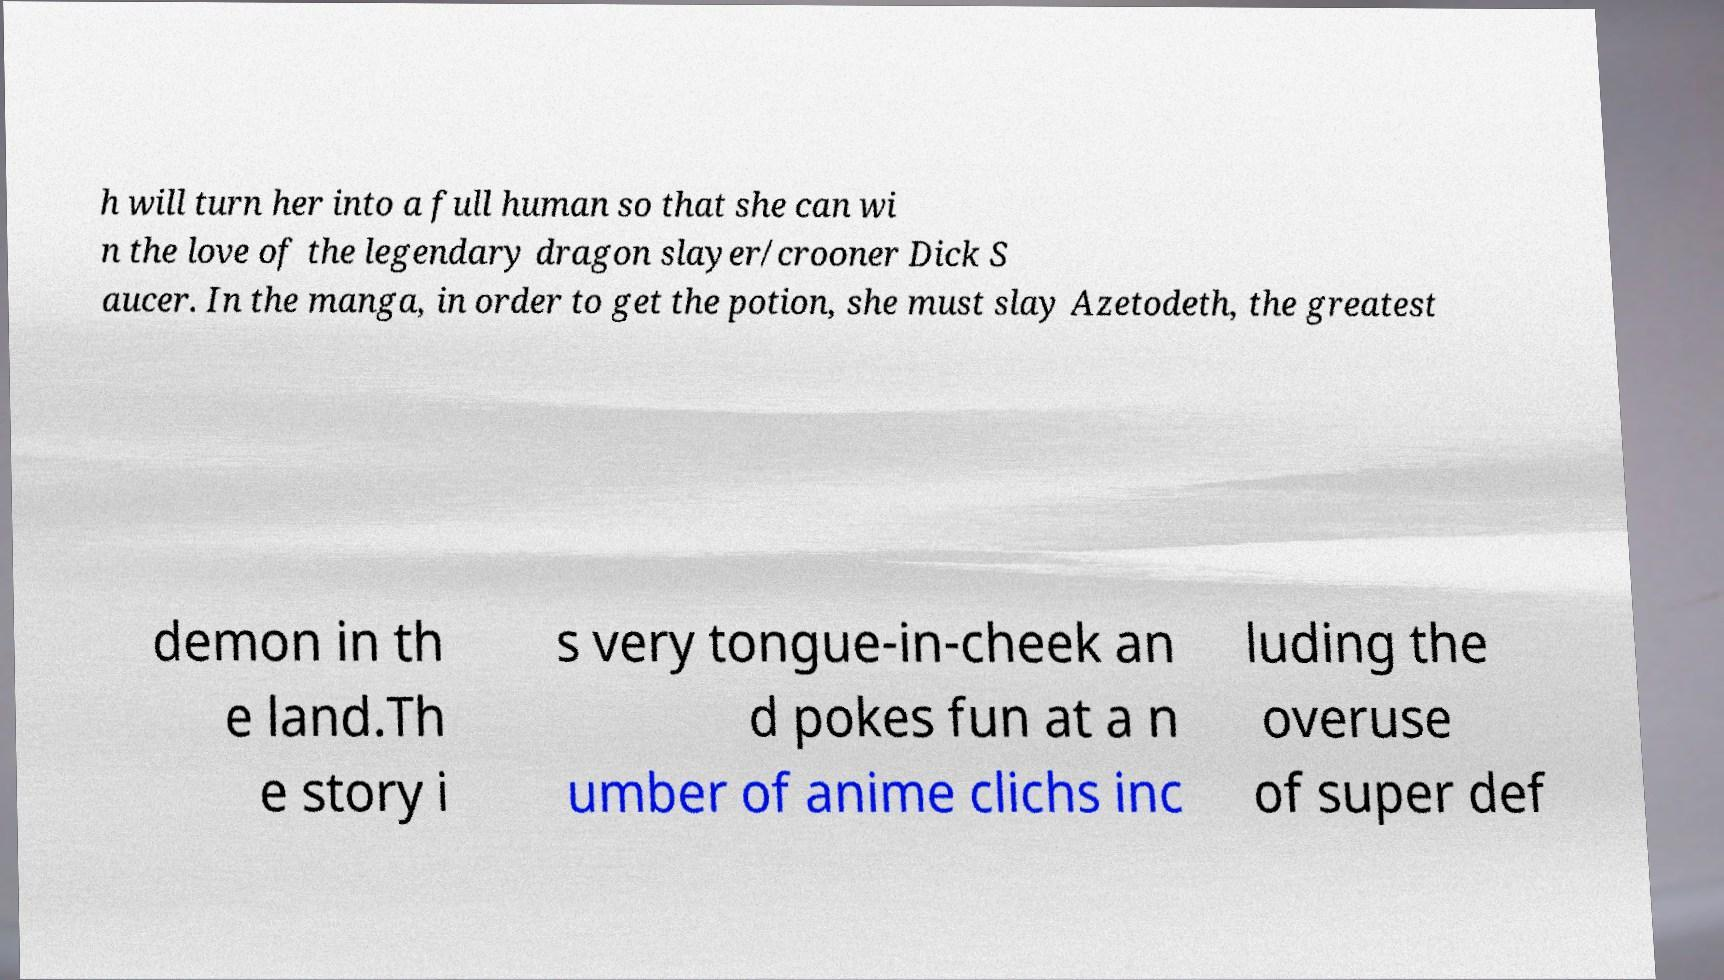Can you accurately transcribe the text from the provided image for me? h will turn her into a full human so that she can wi n the love of the legendary dragon slayer/crooner Dick S aucer. In the manga, in order to get the potion, she must slay Azetodeth, the greatest demon in th e land.Th e story i s very tongue-in-cheek an d pokes fun at a n umber of anime clichs inc luding the overuse of super def 